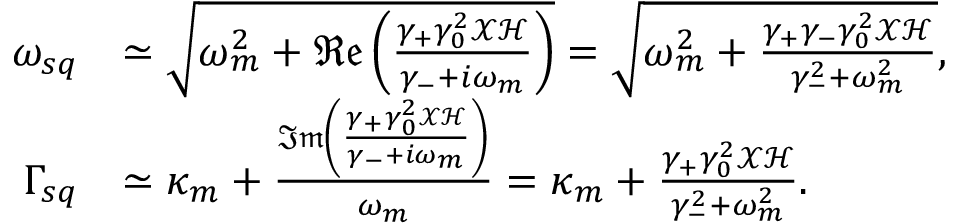Convert formula to latex. <formula><loc_0><loc_0><loc_500><loc_500>\begin{array} { r l } { \omega _ { s q } } & { \simeq \sqrt { \omega _ { m } ^ { 2 } + \mathfrak { R e } \left ( \frac { \gamma _ { + } \gamma _ { 0 } ^ { 2 } \mathcal { X } \mathcal { H } } { \gamma _ { - } + i \omega _ { m } } \right ) } = \sqrt { \omega _ { m } ^ { 2 } + \frac { \gamma _ { + } \gamma _ { - } \gamma _ { 0 } ^ { 2 } \mathcal { X } \mathcal { H } } { \gamma _ { - } ^ { 2 } + \omega _ { m } ^ { 2 } } } , } \\ { \Gamma _ { s q } } & { \simeq \kappa _ { m } + \frac { \mathfrak { I m } \left ( \frac { \gamma _ { + } \gamma _ { 0 } ^ { 2 } \mathcal { X } \mathcal { H } } { \gamma _ { - } + i \omega _ { m } } \right ) } { \omega _ { m } } = \kappa _ { m } + \frac { \gamma _ { + } \gamma _ { 0 } ^ { 2 } \mathcal { X } \mathcal { H } } { \gamma _ { - } ^ { 2 } + \omega _ { m } ^ { 2 } } . } \end{array}</formula> 